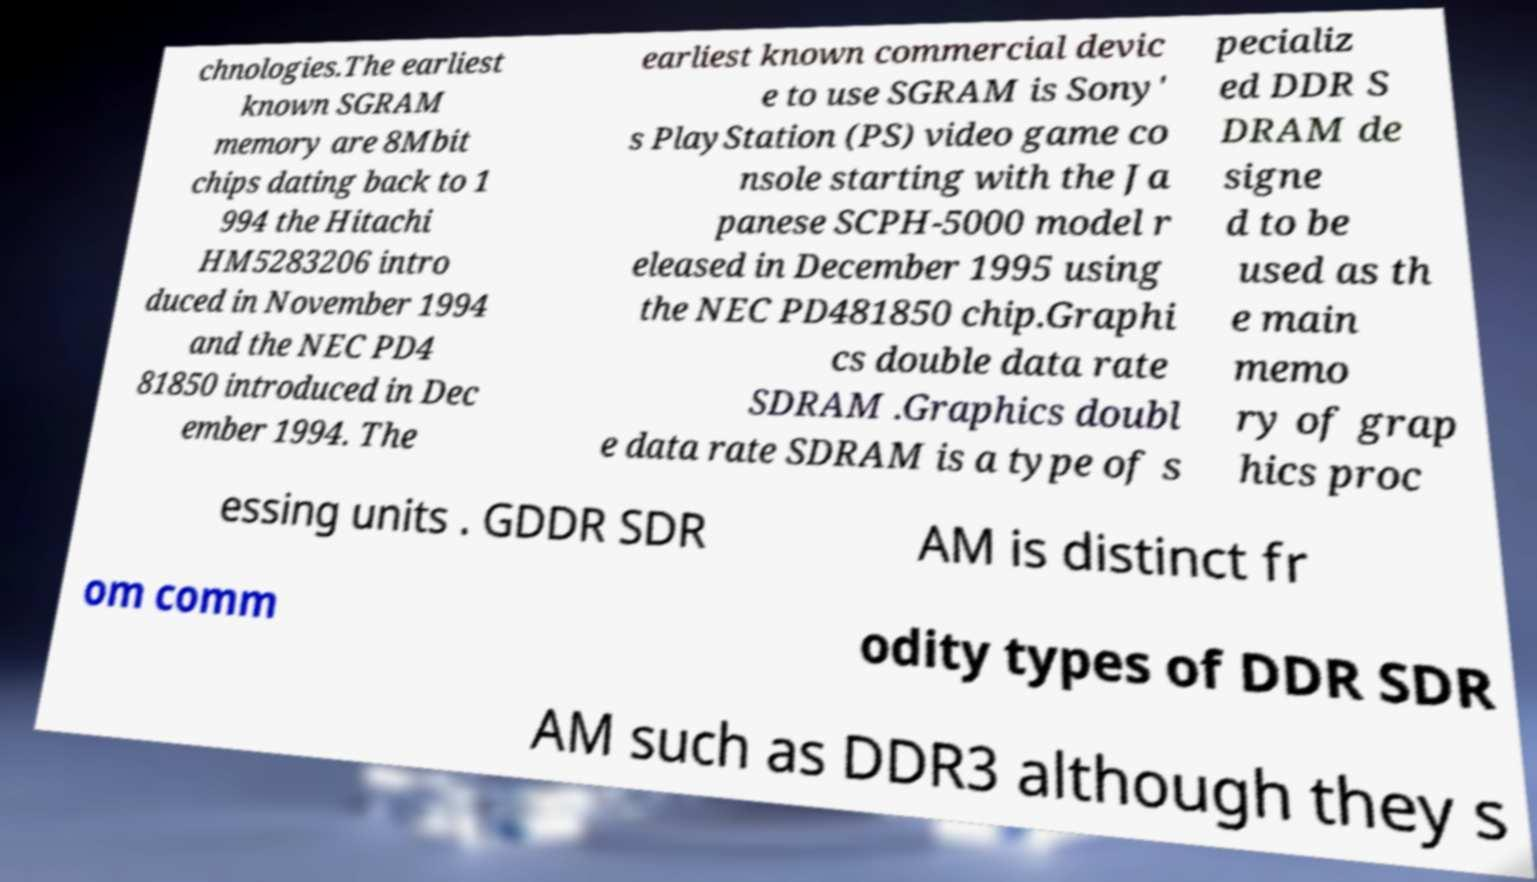Can you read and provide the text displayed in the image?This photo seems to have some interesting text. Can you extract and type it out for me? chnologies.The earliest known SGRAM memory are 8Mbit chips dating back to 1 994 the Hitachi HM5283206 intro duced in November 1994 and the NEC PD4 81850 introduced in Dec ember 1994. The earliest known commercial devic e to use SGRAM is Sony' s PlayStation (PS) video game co nsole starting with the Ja panese SCPH-5000 model r eleased in December 1995 using the NEC PD481850 chip.Graphi cs double data rate SDRAM .Graphics doubl e data rate SDRAM is a type of s pecializ ed DDR S DRAM de signe d to be used as th e main memo ry of grap hics proc essing units . GDDR SDR AM is distinct fr om comm odity types of DDR SDR AM such as DDR3 although they s 